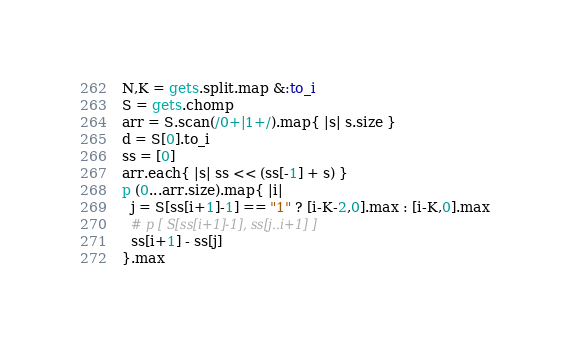Convert code to text. <code><loc_0><loc_0><loc_500><loc_500><_Ruby_>N,K = gets.split.map &:to_i
S = gets.chomp
arr = S.scan(/0+|1+/).map{ |s| s.size }
d = S[0].to_i
ss = [0]
arr.each{ |s| ss << (ss[-1] + s) }
p (0...arr.size).map{ |i|
  j = S[ss[i+1]-1] == "1" ? [i-K-2,0].max : [i-K,0].max
  # p [ S[ss[i+1]-1], ss[j..i+1] ]
  ss[i+1] - ss[j]
}.max
</code> 